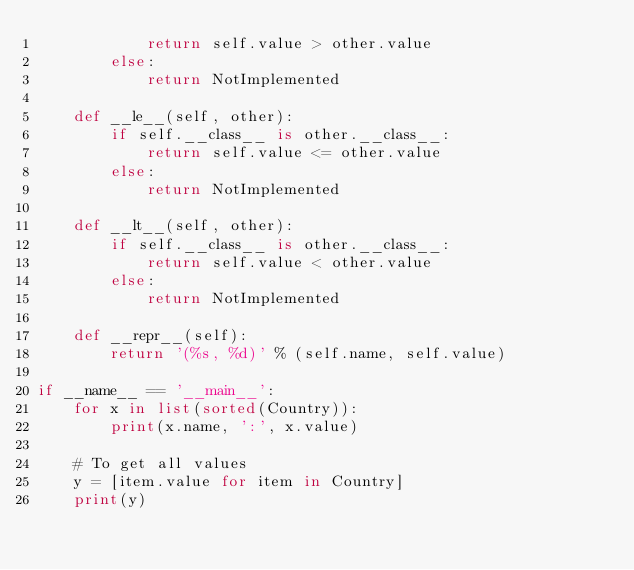<code> <loc_0><loc_0><loc_500><loc_500><_Python_>            return self.value > other.value
        else:
            return NotImplemented

    def __le__(self, other):
        if self.__class__ is other.__class__:
            return self.value <= other.value
        else:
            return NotImplemented

    def __lt__(self, other):
        if self.__class__ is other.__class__:
            return self.value < other.value
        else:
            return NotImplemented

    def __repr__(self):
        return '(%s, %d)' % (self.name, self.value)

if __name__ == '__main__':
    for x in list(sorted(Country)):
        print(x.name, ':', x.value)

    # To get all values
    y = [item.value for item in Country]
    print(y)

</code> 